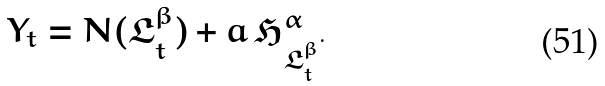Convert formula to latex. <formula><loc_0><loc_0><loc_500><loc_500>Y _ { t } = N ( \mathfrak { L } ^ { \beta } _ { t } ) + a \, \mathfrak { H } ^ { \alpha } _ { \mathfrak { L } ^ { \beta } _ { t } } .</formula> 